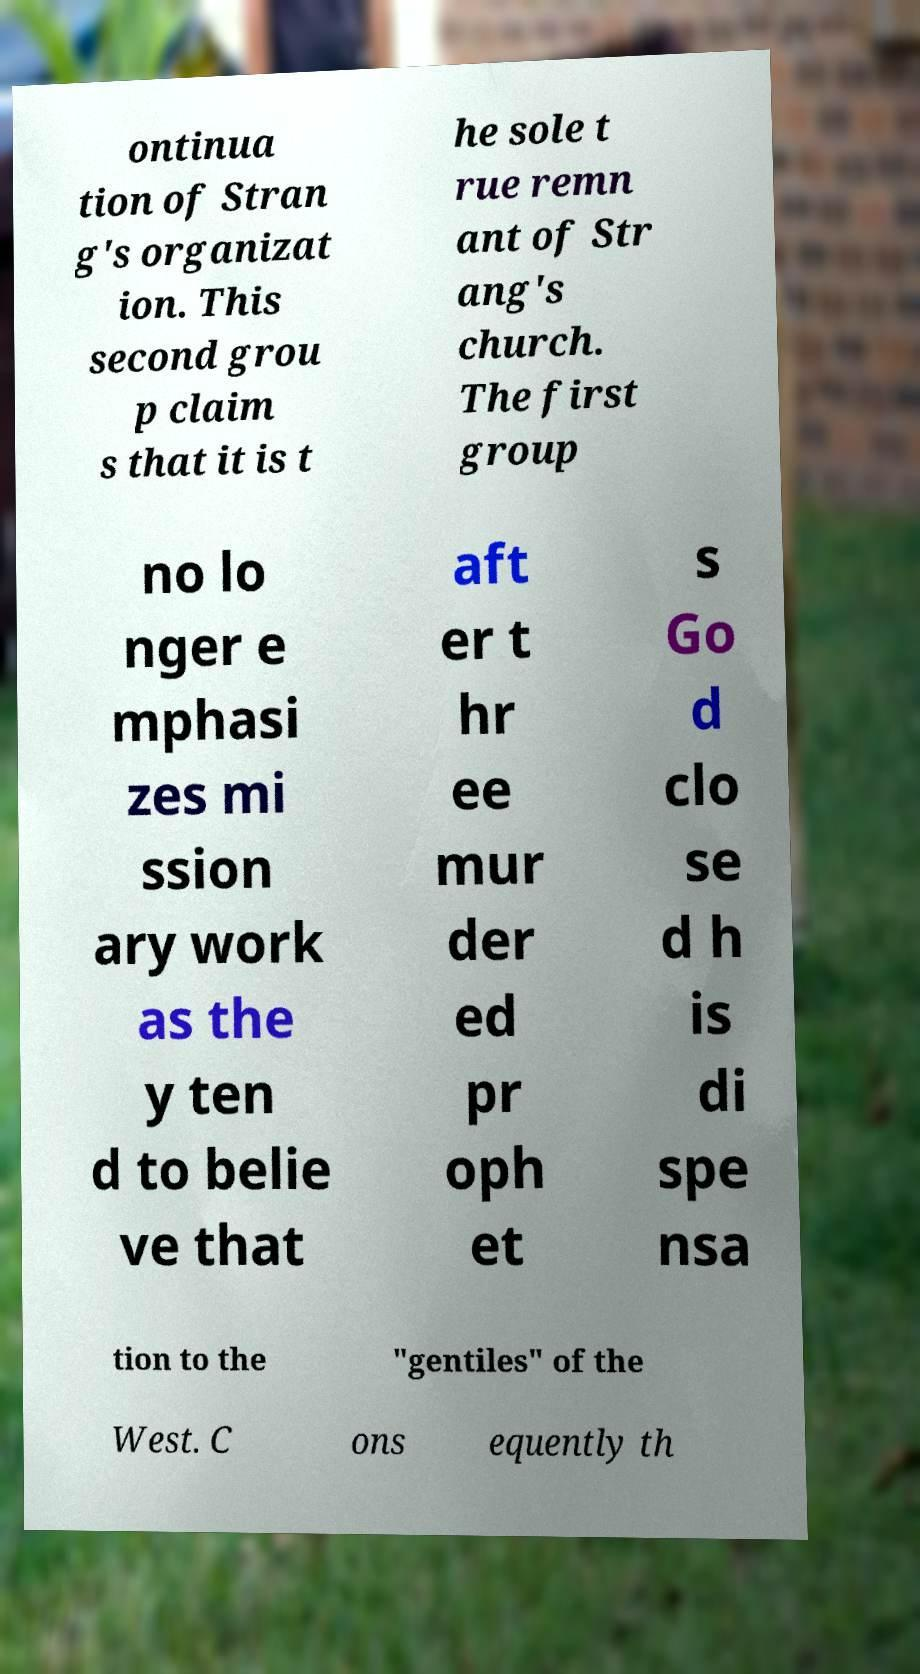Could you assist in decoding the text presented in this image and type it out clearly? ontinua tion of Stran g's organizat ion. This second grou p claim s that it is t he sole t rue remn ant of Str ang's church. The first group no lo nger e mphasi zes mi ssion ary work as the y ten d to belie ve that aft er t hr ee mur der ed pr oph et s Go d clo se d h is di spe nsa tion to the "gentiles" of the West. C ons equently th 